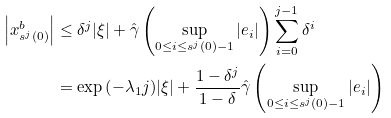Convert formula to latex. <formula><loc_0><loc_0><loc_500><loc_500>\left | x ^ { b } _ { s ^ { j } ( 0 ) } \right | & \leq \delta ^ { j } | \xi | + \hat { \gamma } \left ( \sup _ { 0 \leq i \leq s ^ { j } ( 0 ) - 1 } | e _ { i } | \right ) \sum _ { i = 0 } ^ { j - 1 } \delta ^ { i } \\ & = \exp { \left ( - \lambda _ { 1 } j \right ) } | \xi | + \frac { 1 - \delta ^ { j } } { 1 - \delta } \hat { \gamma } \left ( \sup _ { 0 \leq i \leq s ^ { j } ( 0 ) - 1 } | e _ { i } | \right )</formula> 